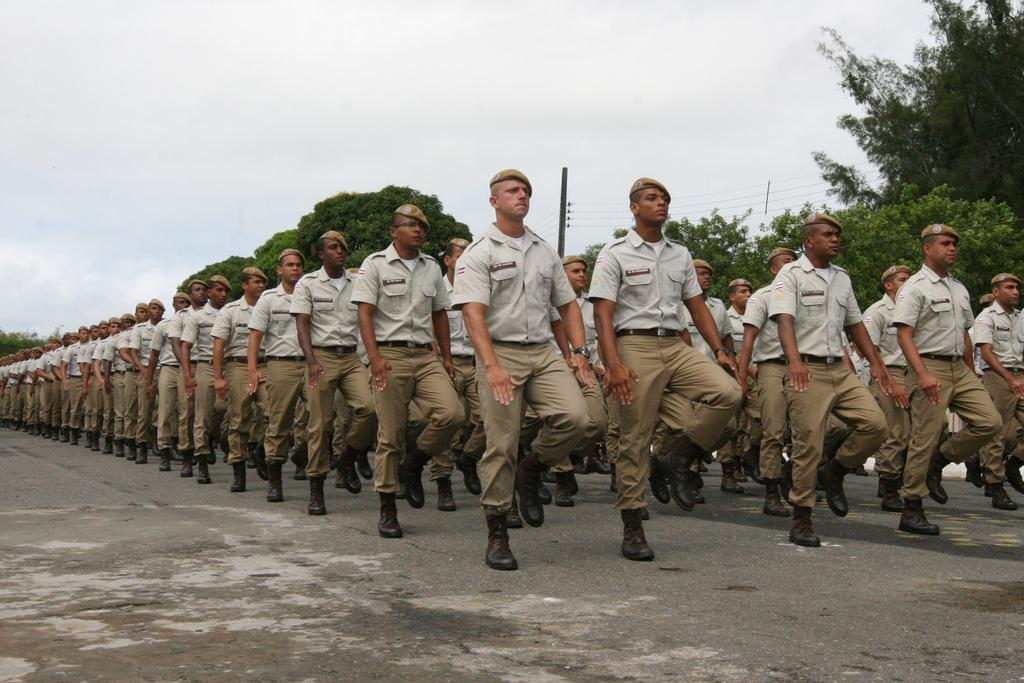What type of people can be seen in the image? There are soldiers in the image. What are the soldiers doing in the image? The soldiers are drilling on a road. What can be seen in the background of the image? There are trees and clouds in the sky in the background of the image. What type of request can be seen being made by the soldiers in the image? There is no request being made by the soldiers in the image; they are drilling on a road. What is the zinc content of the trees in the background of the image? There is no information about the zinc content of the trees in the image, as the focus is on the soldiers and their activity. 